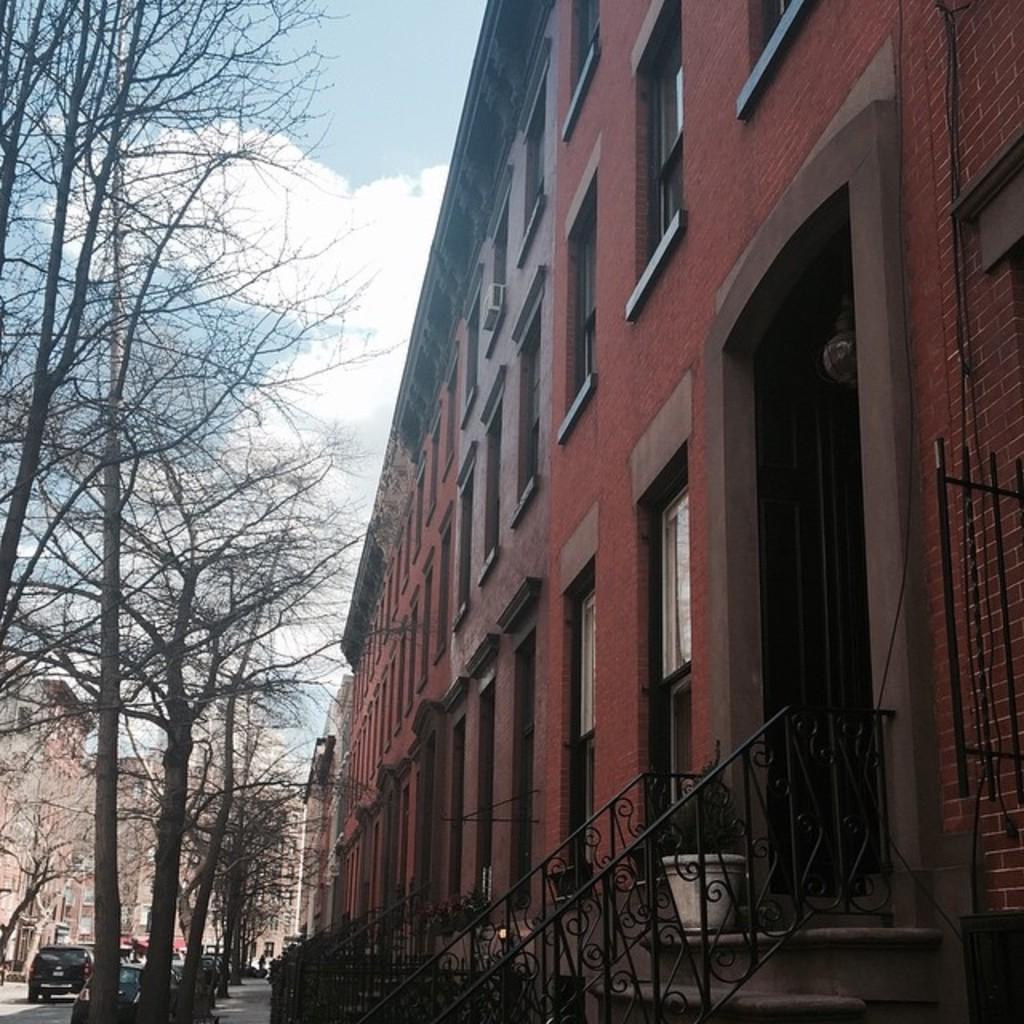How would you summarize this image in a sentence or two? In this image we can see some buildings and there are some trees on the sidewalk and we can see some vehicles on the road. We can see a flower pot with a plant and at the top we can see the sky. 